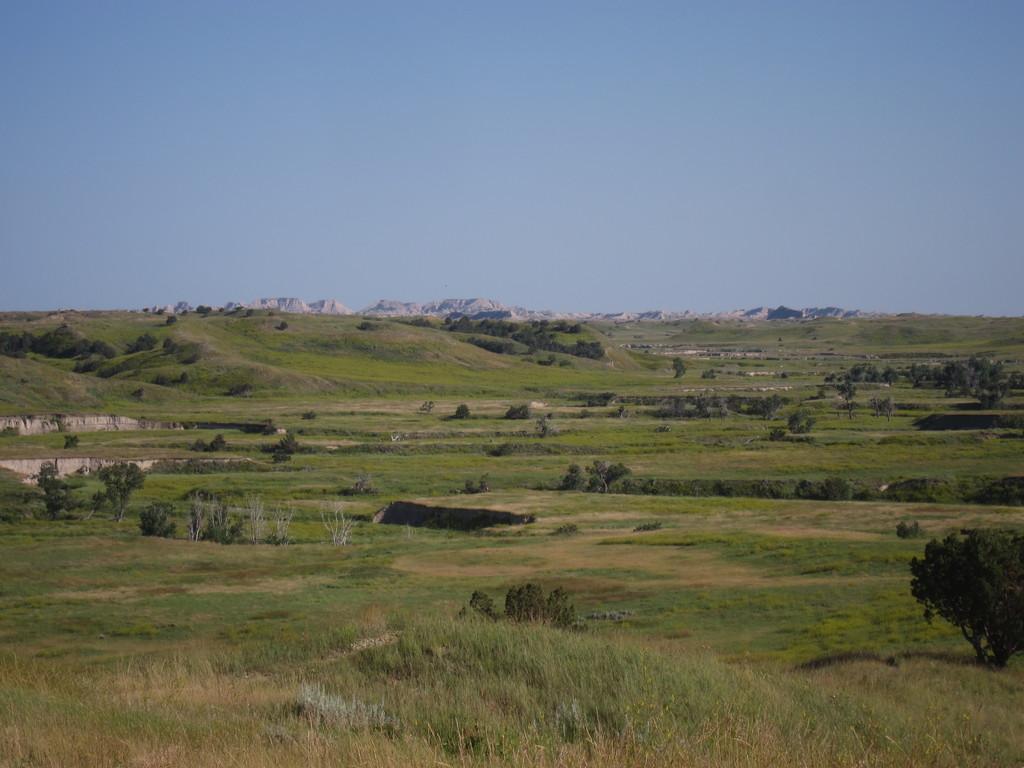Could you give a brief overview of what you see in this image? This is an outside view. Here I can see the grass and trees on the ground. In the background there are some hills. On the top of the image I can see the sky. 